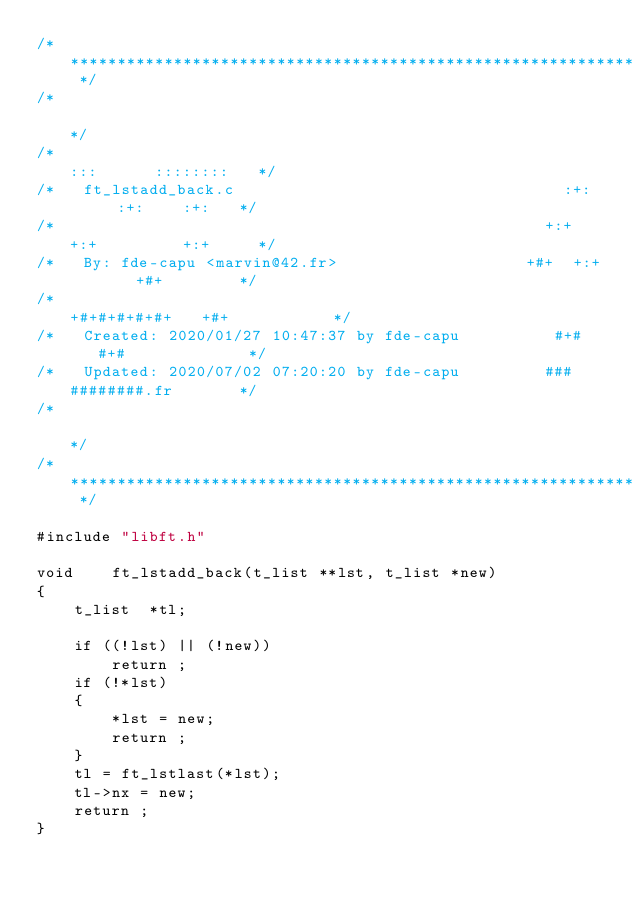Convert code to text. <code><loc_0><loc_0><loc_500><loc_500><_C_>/* ************************************************************************** */
/*                                                                            */
/*                                                        :::      ::::::::   */
/*   ft_lstadd_back.c                                   :+:      :+:    :+:   */
/*                                                    +:+ +:+         +:+     */
/*   By: fde-capu <marvin@42.fr>                    +#+  +:+       +#+        */
/*                                                +#+#+#+#+#+   +#+           */
/*   Created: 2020/01/27 10:47:37 by fde-capu          #+#    #+#             */
/*   Updated: 2020/07/02 07:20:20 by fde-capu         ###   ########.fr       */
/*                                                                            */
/* ************************************************************************** */

#include "libft.h"

void	ft_lstadd_back(t_list **lst, t_list *new)
{
	t_list	*tl;

	if ((!lst) || (!new))
		return ;
	if (!*lst)
	{
		*lst = new;
		return ;
	}
	tl = ft_lstlast(*lst);
	tl->nx = new;
	return ;
}
</code> 